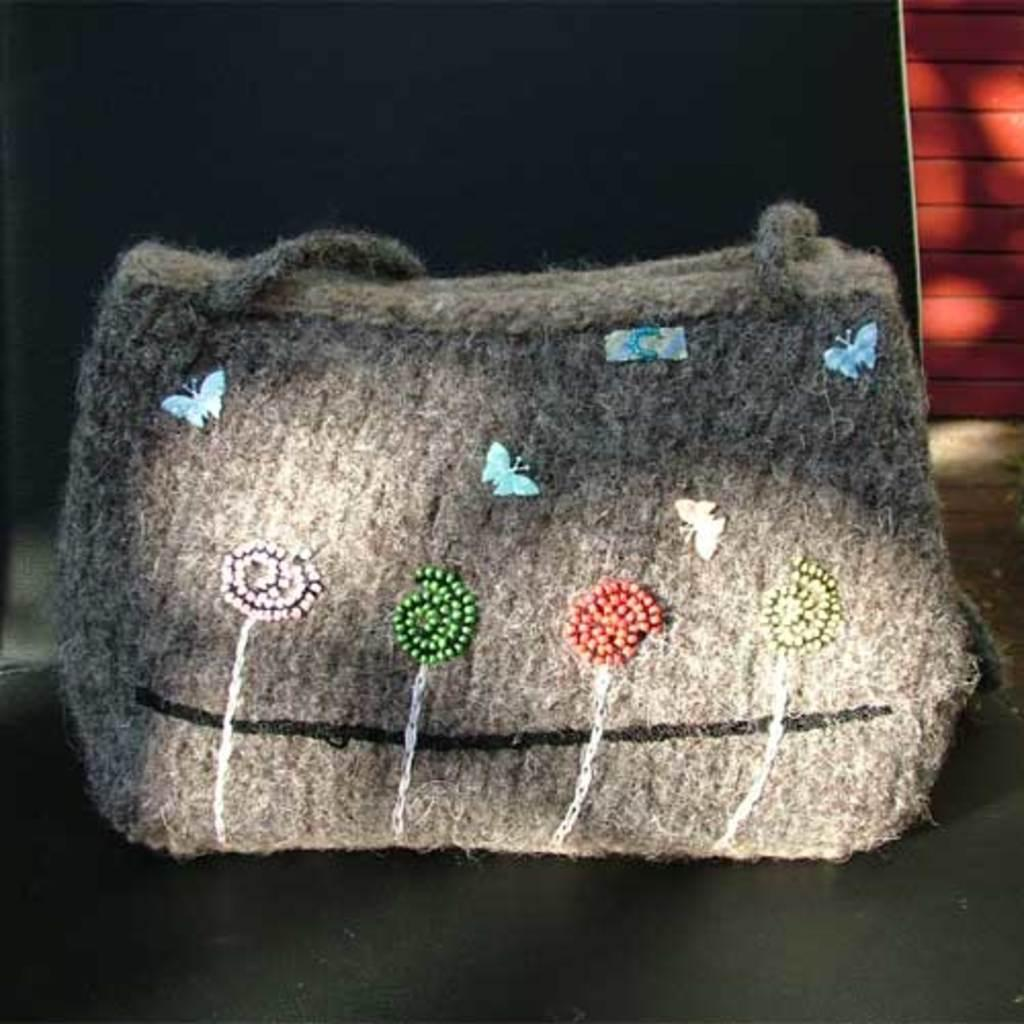What object is present in the image? There is a bag in the image. What design or pattern is on the bag? There are butterflies on the bag. How does the bag use its mouth to swim in the image? The bag does not have a mouth or the ability to swim, as it is an inanimate object. 